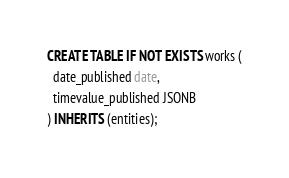<code> <loc_0><loc_0><loc_500><loc_500><_SQL_>CREATE TABLE IF NOT EXISTS works (
  date_published date,
  timevalue_published JSONB
) INHERITS (entities);
</code> 